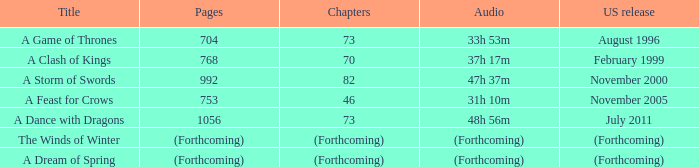Which us issue contains 704 pages? August 1996. 